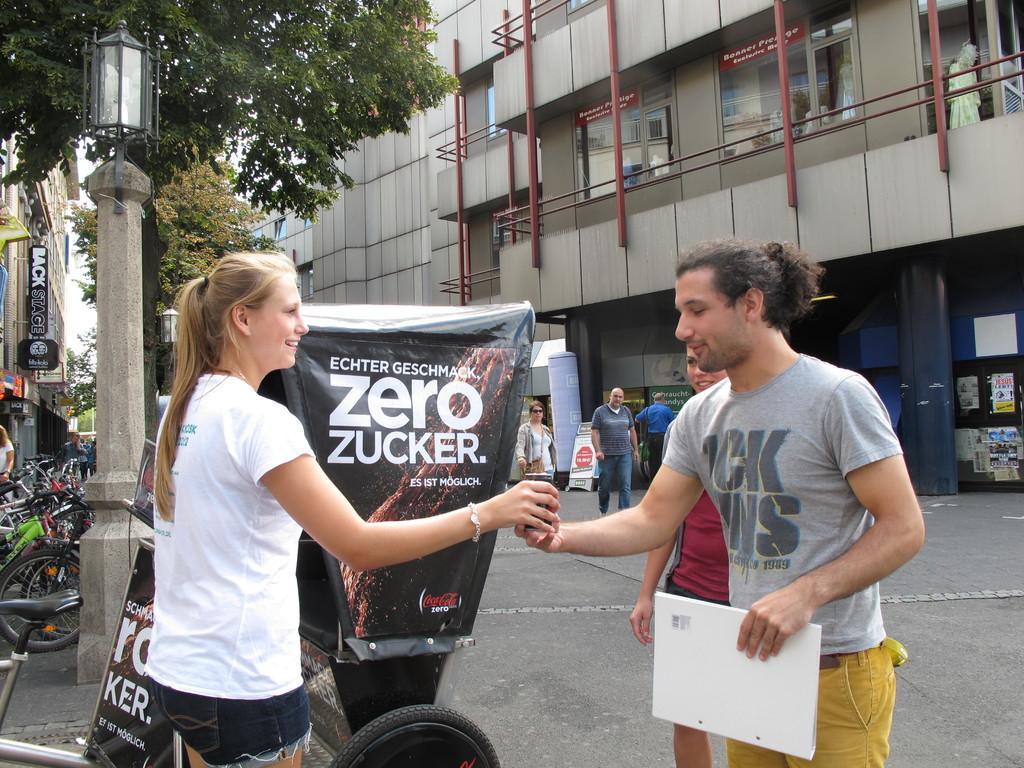Describe this image in one or two sentences. On the left side of the image we can see bicycles are parked. In the middle of the image we can see a lady where she is wearing a white color dress and giving something to a man. On the right side of the image we can see a person holding a file in his hand and taking something from the lady and a building is there. 